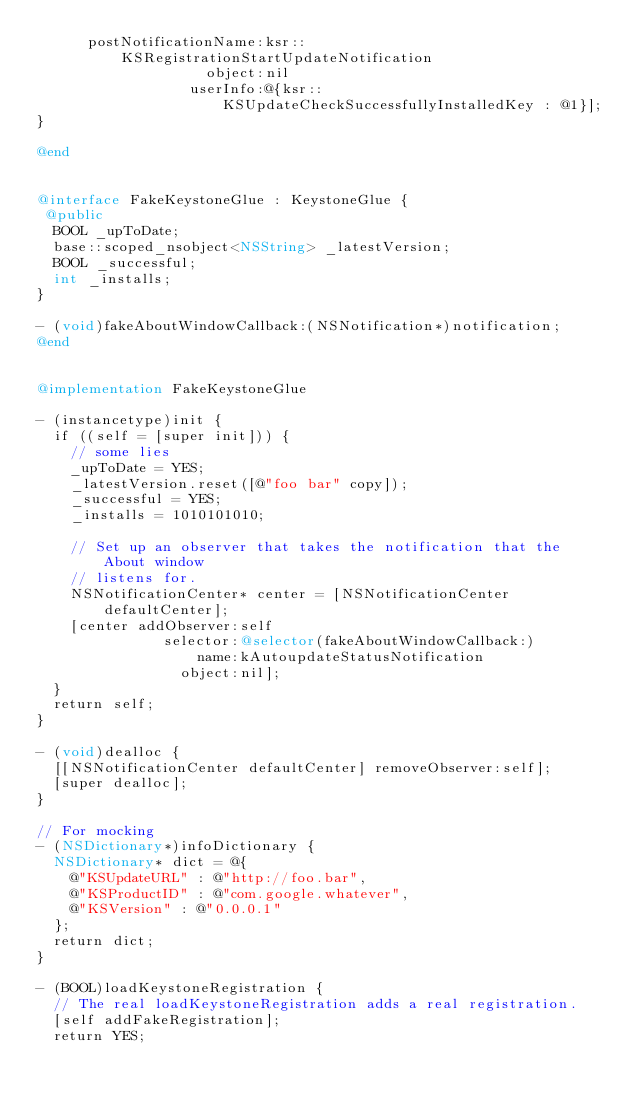<code> <loc_0><loc_0><loc_500><loc_500><_ObjectiveC_>      postNotificationName:ksr::KSRegistrationStartUpdateNotification
                    object:nil
                  userInfo:@{ksr::KSUpdateCheckSuccessfullyInstalledKey : @1}];
}

@end


@interface FakeKeystoneGlue : KeystoneGlue {
 @public
  BOOL _upToDate;
  base::scoped_nsobject<NSString> _latestVersion;
  BOOL _successful;
  int _installs;
}

- (void)fakeAboutWindowCallback:(NSNotification*)notification;
@end


@implementation FakeKeystoneGlue

- (instancetype)init {
  if ((self = [super init])) {
    // some lies
    _upToDate = YES;
    _latestVersion.reset([@"foo bar" copy]);
    _successful = YES;
    _installs = 1010101010;

    // Set up an observer that takes the notification that the About window
    // listens for.
    NSNotificationCenter* center = [NSNotificationCenter defaultCenter];
    [center addObserver:self
               selector:@selector(fakeAboutWindowCallback:)
                   name:kAutoupdateStatusNotification
                 object:nil];
  }
  return self;
}

- (void)dealloc {
  [[NSNotificationCenter defaultCenter] removeObserver:self];
  [super dealloc];
}

// For mocking
- (NSDictionary*)infoDictionary {
  NSDictionary* dict = @{
    @"KSUpdateURL" : @"http://foo.bar",
    @"KSProductID" : @"com.google.whatever",
    @"KSVersion" : @"0.0.0.1"
  };
  return dict;
}

- (BOOL)loadKeystoneRegistration {
  // The real loadKeystoneRegistration adds a real registration.
  [self addFakeRegistration];
  return YES;</code> 